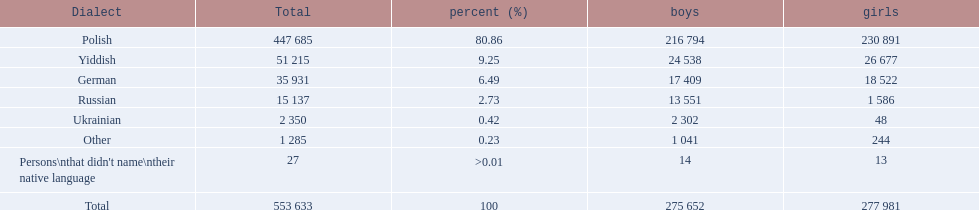What was the highest percentage of one language spoken by the plock governorate? 80.86. What language was spoken by 80.86 percent of the people? Polish. 